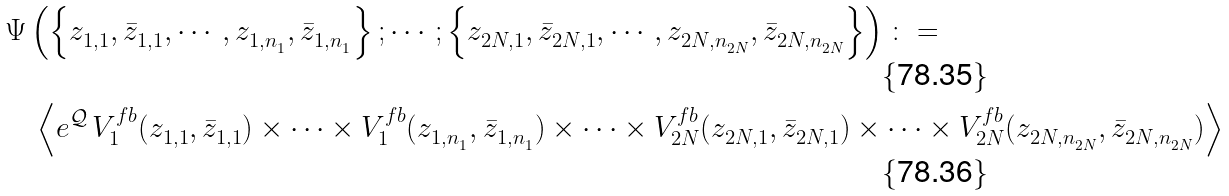<formula> <loc_0><loc_0><loc_500><loc_500>& \Psi \left ( \left \{ z ^ { \ } _ { 1 , 1 } , \bar { z } ^ { \ } _ { 1 , 1 } , \cdots , z ^ { \ } _ { 1 , n ^ { \ } _ { 1 } } , \bar { z } ^ { \ } _ { 1 , n ^ { \ } _ { 1 } } \right \} ; \cdots ; \left \{ z ^ { \ } _ { 2 N , 1 } , \bar { z } ^ { \ } _ { 2 N , 1 } , \cdots , z ^ { \ } _ { 2 N , n ^ { \ } _ { 2 N } } , \bar { z } ^ { \ } _ { 2 N , n ^ { \ } _ { 2 N } } \right \} \right ) \colon = \\ & \quad \left \langle e ^ { \mathcal { Q } } \, V ^ { f b } _ { 1 } ( z ^ { \ } _ { 1 , 1 } , \bar { z } ^ { \ } _ { 1 , 1 } ) \times \cdots \times V ^ { f b } _ { 1 } ( z ^ { \ } _ { 1 , n ^ { \ } _ { 1 } } , \bar { z } ^ { \ } _ { 1 , n ^ { \ } _ { 1 } } ) \times \cdots \times V ^ { f b } _ { 2 N } ( z ^ { \ } _ { 2 N , 1 } , \bar { z } ^ { \ } _ { 2 N , 1 } ) \times \cdots \times V ^ { f b } _ { 2 N } ( z ^ { \ } _ { 2 N , n ^ { \ } _ { 2 N } } , \bar { z } ^ { \ } _ { 2 N , n ^ { \ } _ { 2 N } } ) \right \rangle</formula> 